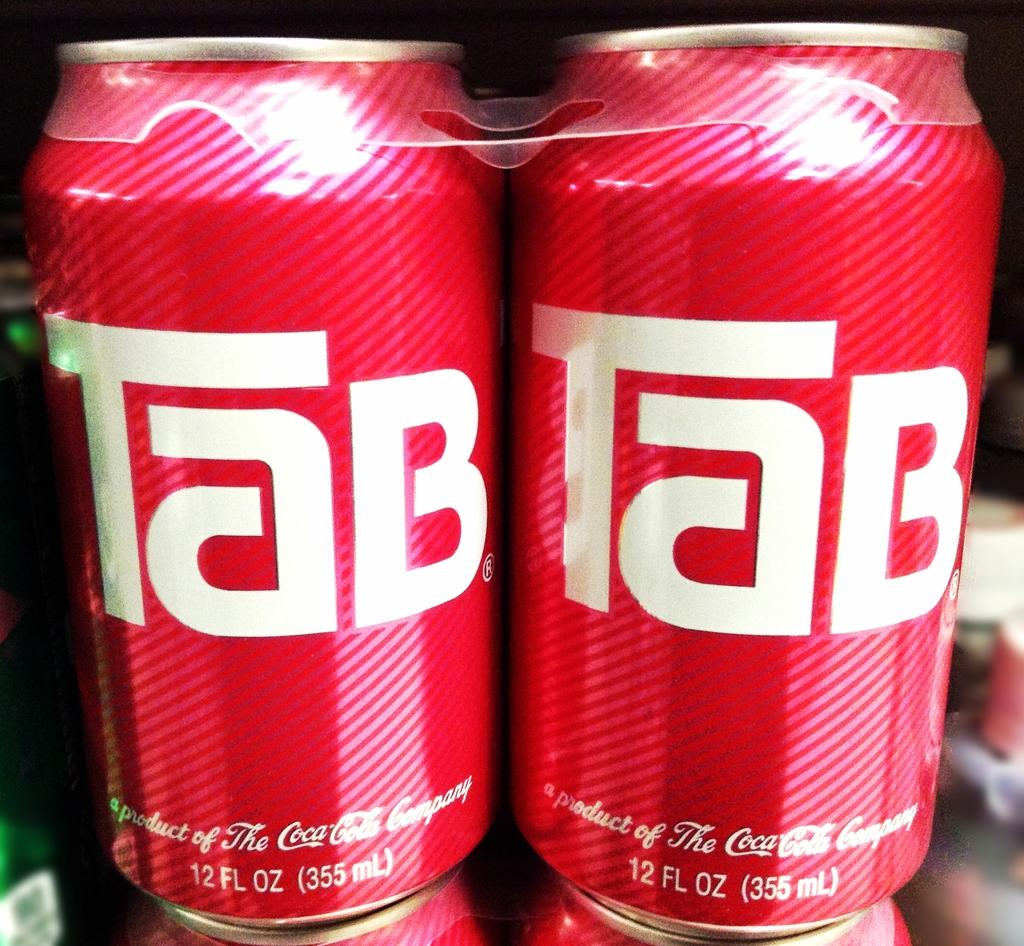<image>
Relay a brief, clear account of the picture shown. A stack of Tab cans of soda by the Coca Cola company. 